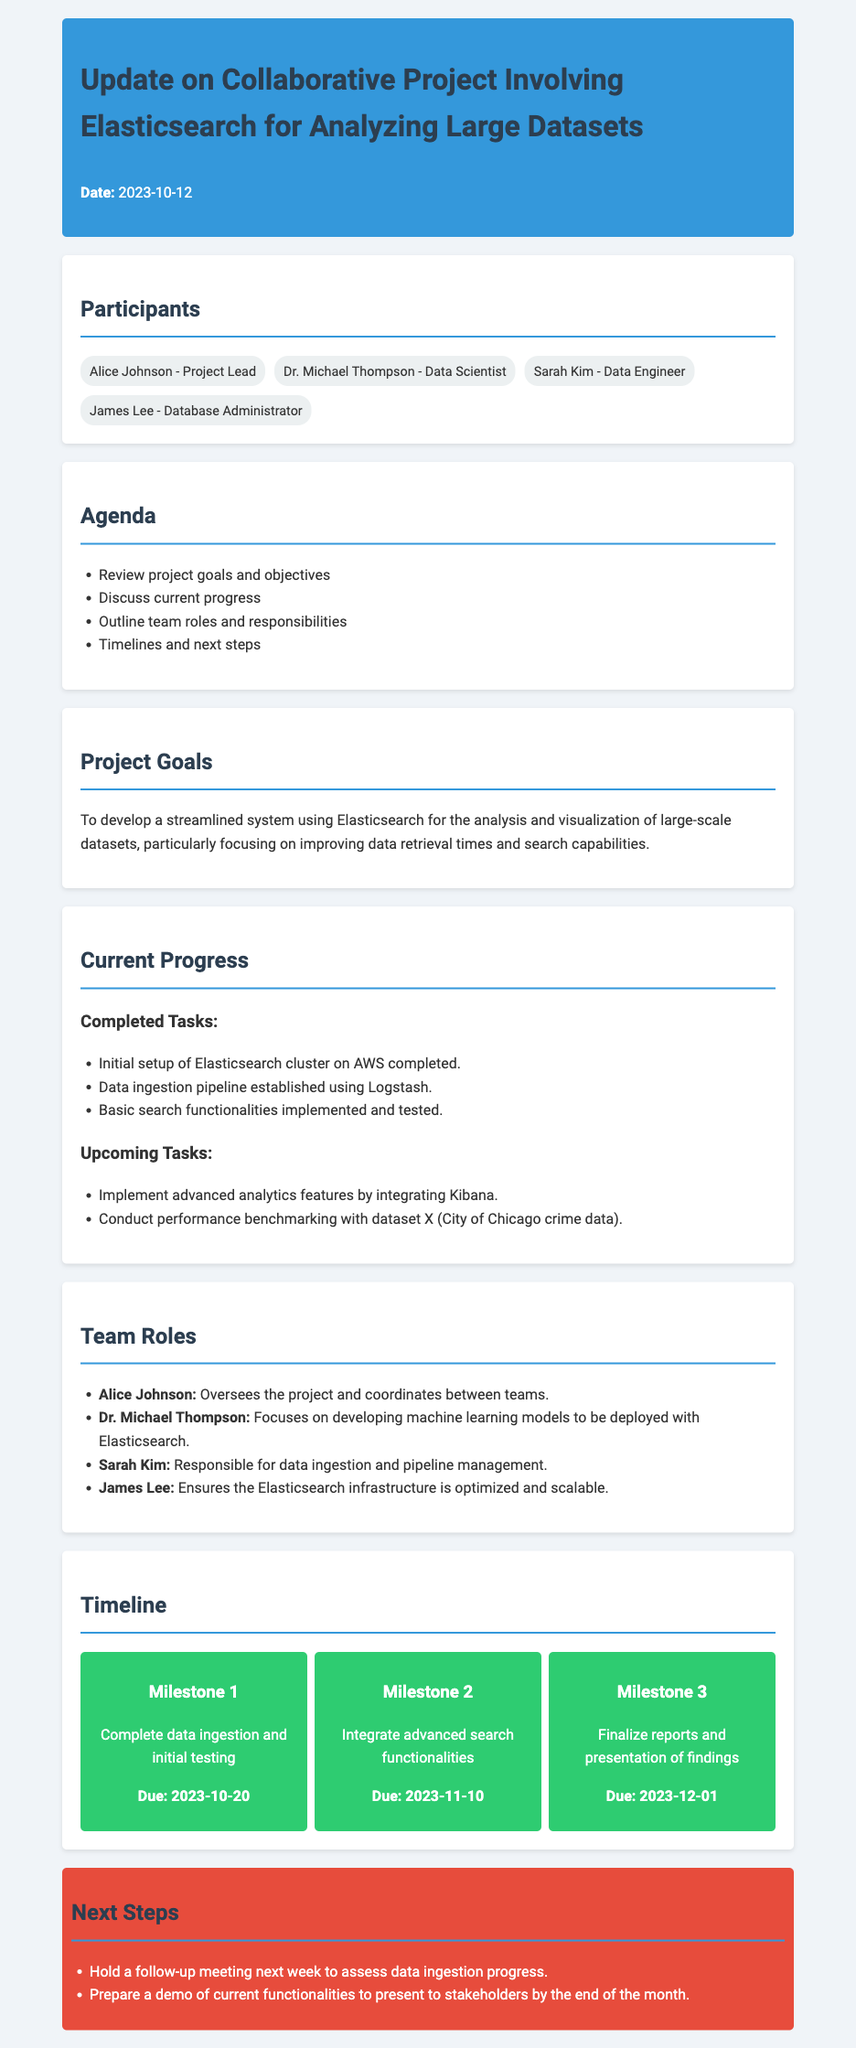What is the date of the meeting? The date of the meeting is stated at the top of the document in the header section.
Answer: 2023-10-12 Who is the project lead? The project lead is mentioned in the participants section of the document.
Answer: Alice Johnson What is the first completed task? The completed tasks section lists the tasks in a specific order, with the first being the setup of the cluster.
Answer: Initial setup of Elasticsearch cluster on AWS completed What is the deadline for Milestone 2? The timeline section provides due dates for each milestone, with Milestone 2 due date stated.
Answer: 2023-11-10 Which participant focuses on machine learning models? The team roles section specifies the responsibilities of each member, identifying the one who focuses on machine learning.
Answer: Dr. Michael Thompson What are the next steps? The next steps section outlines specific actions to be taken immediately following the meeting.
Answer: Hold a follow-up meeting next week to assess data ingestion progress What is the main project goal? The project goals section provides a clear statement of the overall objective of the project.
Answer: To develop a streamlined system using Elasticsearch for the analysis and visualization of large-scale datasets How many upcoming tasks are listed? The current progress section lists the tasks under the upcoming tasks heading, allowing us to count them.
Answer: 2 What is James Lee's role in the project? The team roles section describes responsibilities for each team member, including James Lee's specific duties.
Answer: Ensures the Elasticsearch infrastructure is optimized and scalable 